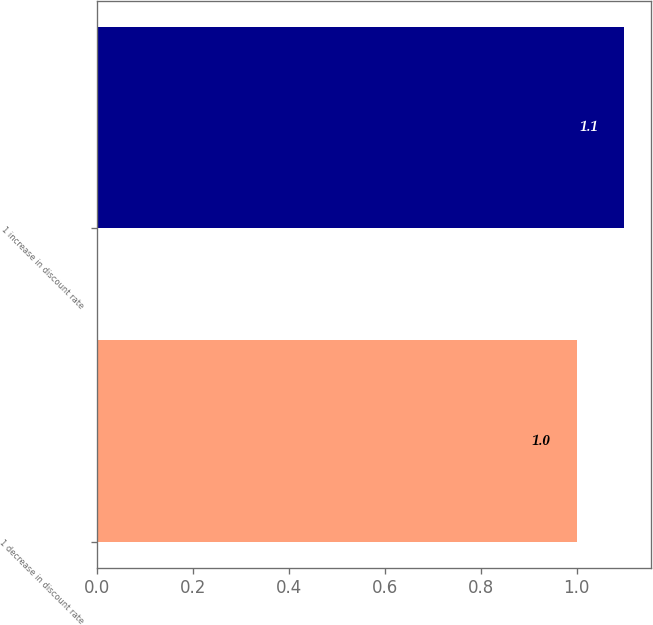Convert chart to OTSL. <chart><loc_0><loc_0><loc_500><loc_500><bar_chart><fcel>1 decrease in discount rate<fcel>1 increase in discount rate<nl><fcel>1<fcel>1.1<nl></chart> 